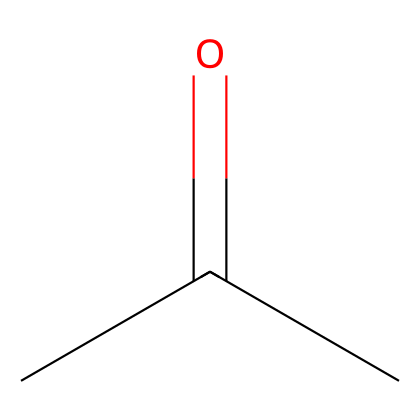What is the molecular formula of this compound? The compound has three carbon (C) atoms, six hydrogen (H) atoms, and one oxygen (O) atom based on the SMILES representation. Thus, the molecular formula can be derived as C3H6O.
Answer: C3H6O How many carbon atoms are present in this structure? By examining the SMILES representation, there are three carbon atoms indicated. The "CC" suggests two carbon atoms in a chain followed by the "=O" which indicates a functional group related to carbon, leading to a total of three.
Answer: 3 What type of functional group is present in this chemical? The "=O" part of the SMILES indicates a carbonyl group, which is characteristic of ketones. Since the structure has two carbon atoms adjacent to the carbonyl, it confirms that this is indeed a ketone.
Answer: carbonyl What is the hybridization of the carbon atoms in the carbonyl group? The carbon atom in the carbonyl group is bonded to one oxygen atom via a double bond and to two other carbon atoms, which leads to sp2 hybridization due to the trigonal planar arrangement of bonds around the carbon atom.
Answer: sp2 Which part of the structure is responsible for the solvent properties? The carbonyl functional group ("=O") has polar characteristics that allows for interaction with various solvents, thus contributing to the compound's effectiveness as a solvent.
Answer: carbonyl group Is this compound classified as saturated or unsaturated? Since there are no carbon-carbon double bonds in the main carbon chain (aside from the carbonyl), and all carbon atoms have the maximum number of hydrogen atoms attached, this compound is saturated.
Answer: saturated 